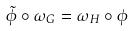<formula> <loc_0><loc_0><loc_500><loc_500>\tilde { \phi } \circ \omega _ { G } = \omega _ { H } \circ \phi</formula> 